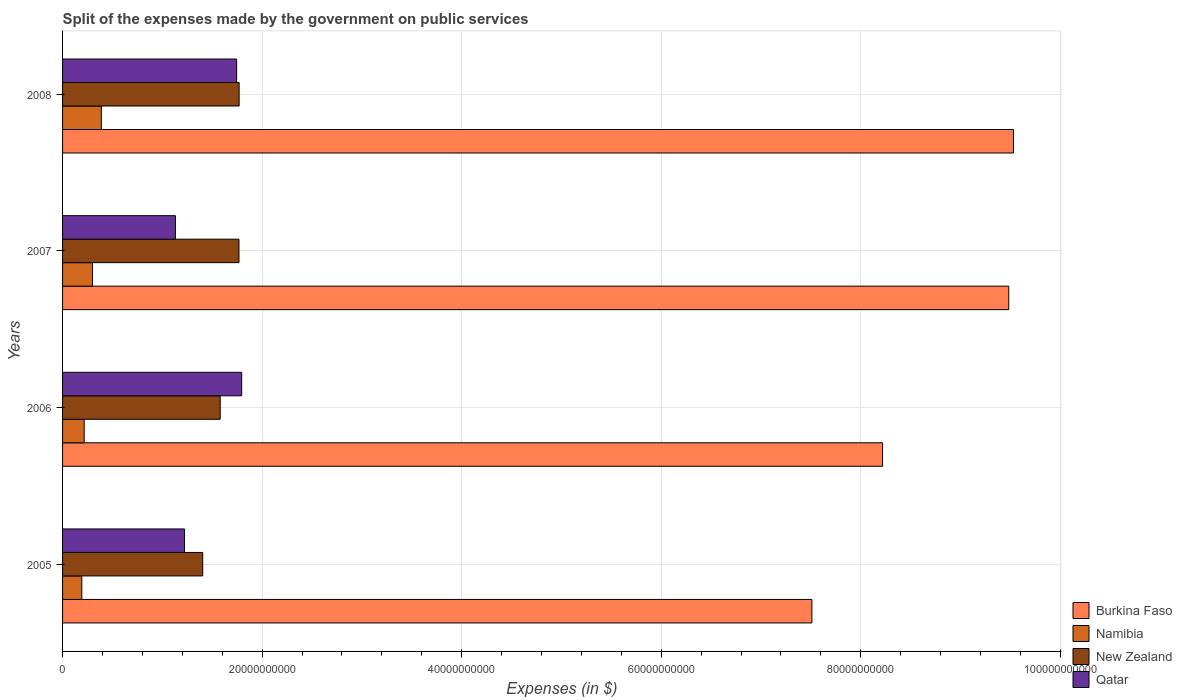How many different coloured bars are there?
Offer a very short reply. 4. How many groups of bars are there?
Offer a terse response. 4. Are the number of bars per tick equal to the number of legend labels?
Ensure brevity in your answer.  Yes. Are the number of bars on each tick of the Y-axis equal?
Keep it short and to the point. Yes. How many bars are there on the 3rd tick from the top?
Give a very brief answer. 4. What is the label of the 1st group of bars from the top?
Give a very brief answer. 2008. What is the expenses made by the government on public services in New Zealand in 2005?
Provide a short and direct response. 1.40e+1. Across all years, what is the maximum expenses made by the government on public services in Namibia?
Offer a very short reply. 3.89e+09. Across all years, what is the minimum expenses made by the government on public services in Qatar?
Ensure brevity in your answer.  1.13e+1. In which year was the expenses made by the government on public services in Qatar minimum?
Provide a succinct answer. 2007. What is the total expenses made by the government on public services in Namibia in the graph?
Offer a very short reply. 1.10e+1. What is the difference between the expenses made by the government on public services in Qatar in 2007 and that in 2008?
Provide a succinct answer. -6.14e+09. What is the difference between the expenses made by the government on public services in New Zealand in 2005 and the expenses made by the government on public services in Qatar in 2007?
Provide a succinct answer. 2.74e+09. What is the average expenses made by the government on public services in Burkina Faso per year?
Offer a very short reply. 8.69e+1. In the year 2006, what is the difference between the expenses made by the government on public services in Burkina Faso and expenses made by the government on public services in Namibia?
Offer a very short reply. 8.00e+1. What is the ratio of the expenses made by the government on public services in Qatar in 2007 to that in 2008?
Your answer should be compact. 0.65. Is the expenses made by the government on public services in Namibia in 2007 less than that in 2008?
Make the answer very short. Yes. Is the difference between the expenses made by the government on public services in Burkina Faso in 2005 and 2007 greater than the difference between the expenses made by the government on public services in Namibia in 2005 and 2007?
Your response must be concise. No. What is the difference between the highest and the second highest expenses made by the government on public services in Qatar?
Offer a very short reply. 5.07e+08. What is the difference between the highest and the lowest expenses made by the government on public services in New Zealand?
Provide a succinct answer. 3.65e+09. What does the 1st bar from the top in 2006 represents?
Provide a short and direct response. Qatar. What does the 3rd bar from the bottom in 2008 represents?
Ensure brevity in your answer.  New Zealand. How many bars are there?
Your answer should be very brief. 16. Are all the bars in the graph horizontal?
Provide a short and direct response. Yes. What is the difference between two consecutive major ticks on the X-axis?
Provide a short and direct response. 2.00e+1. Are the values on the major ticks of X-axis written in scientific E-notation?
Your response must be concise. No. Does the graph contain any zero values?
Offer a very short reply. No. How are the legend labels stacked?
Make the answer very short. Vertical. What is the title of the graph?
Give a very brief answer. Split of the expenses made by the government on public services. What is the label or title of the X-axis?
Your response must be concise. Expenses (in $). What is the Expenses (in $) in Burkina Faso in 2005?
Provide a succinct answer. 7.51e+1. What is the Expenses (in $) in Namibia in 2005?
Provide a short and direct response. 1.93e+09. What is the Expenses (in $) of New Zealand in 2005?
Keep it short and to the point. 1.40e+1. What is the Expenses (in $) in Qatar in 2005?
Your answer should be compact. 1.22e+1. What is the Expenses (in $) of Burkina Faso in 2006?
Give a very brief answer. 8.22e+1. What is the Expenses (in $) of Namibia in 2006?
Your answer should be very brief. 2.17e+09. What is the Expenses (in $) in New Zealand in 2006?
Offer a very short reply. 1.58e+1. What is the Expenses (in $) of Qatar in 2006?
Your response must be concise. 1.80e+1. What is the Expenses (in $) in Burkina Faso in 2007?
Your answer should be very brief. 9.48e+1. What is the Expenses (in $) in Namibia in 2007?
Make the answer very short. 3.00e+09. What is the Expenses (in $) in New Zealand in 2007?
Ensure brevity in your answer.  1.77e+1. What is the Expenses (in $) in Qatar in 2007?
Give a very brief answer. 1.13e+1. What is the Expenses (in $) of Burkina Faso in 2008?
Keep it short and to the point. 9.53e+1. What is the Expenses (in $) of Namibia in 2008?
Your answer should be very brief. 3.89e+09. What is the Expenses (in $) in New Zealand in 2008?
Provide a short and direct response. 1.77e+1. What is the Expenses (in $) of Qatar in 2008?
Your response must be concise. 1.74e+1. Across all years, what is the maximum Expenses (in $) of Burkina Faso?
Offer a terse response. 9.53e+1. Across all years, what is the maximum Expenses (in $) in Namibia?
Keep it short and to the point. 3.89e+09. Across all years, what is the maximum Expenses (in $) in New Zealand?
Your answer should be compact. 1.77e+1. Across all years, what is the maximum Expenses (in $) in Qatar?
Provide a short and direct response. 1.80e+1. Across all years, what is the minimum Expenses (in $) of Burkina Faso?
Give a very brief answer. 7.51e+1. Across all years, what is the minimum Expenses (in $) of Namibia?
Offer a terse response. 1.93e+09. Across all years, what is the minimum Expenses (in $) in New Zealand?
Provide a succinct answer. 1.40e+1. Across all years, what is the minimum Expenses (in $) in Qatar?
Give a very brief answer. 1.13e+1. What is the total Expenses (in $) in Burkina Faso in the graph?
Your answer should be compact. 3.47e+11. What is the total Expenses (in $) in Namibia in the graph?
Give a very brief answer. 1.10e+1. What is the total Expenses (in $) of New Zealand in the graph?
Your answer should be compact. 6.52e+1. What is the total Expenses (in $) of Qatar in the graph?
Your response must be concise. 5.89e+1. What is the difference between the Expenses (in $) in Burkina Faso in 2005 and that in 2006?
Make the answer very short. -7.08e+09. What is the difference between the Expenses (in $) in Namibia in 2005 and that in 2006?
Give a very brief answer. -2.37e+08. What is the difference between the Expenses (in $) in New Zealand in 2005 and that in 2006?
Your answer should be compact. -1.75e+09. What is the difference between the Expenses (in $) in Qatar in 2005 and that in 2006?
Keep it short and to the point. -5.73e+09. What is the difference between the Expenses (in $) of Burkina Faso in 2005 and that in 2007?
Provide a short and direct response. -1.97e+1. What is the difference between the Expenses (in $) in Namibia in 2005 and that in 2007?
Provide a succinct answer. -1.07e+09. What is the difference between the Expenses (in $) of New Zealand in 2005 and that in 2007?
Provide a succinct answer. -3.63e+09. What is the difference between the Expenses (in $) in Qatar in 2005 and that in 2007?
Offer a terse response. 9.13e+08. What is the difference between the Expenses (in $) in Burkina Faso in 2005 and that in 2008?
Offer a very short reply. -2.02e+1. What is the difference between the Expenses (in $) of Namibia in 2005 and that in 2008?
Provide a short and direct response. -1.96e+09. What is the difference between the Expenses (in $) of New Zealand in 2005 and that in 2008?
Ensure brevity in your answer.  -3.65e+09. What is the difference between the Expenses (in $) in Qatar in 2005 and that in 2008?
Your answer should be compact. -5.22e+09. What is the difference between the Expenses (in $) in Burkina Faso in 2006 and that in 2007?
Your answer should be very brief. -1.26e+1. What is the difference between the Expenses (in $) in Namibia in 2006 and that in 2007?
Provide a short and direct response. -8.32e+08. What is the difference between the Expenses (in $) in New Zealand in 2006 and that in 2007?
Your answer should be very brief. -1.88e+09. What is the difference between the Expenses (in $) in Qatar in 2006 and that in 2007?
Your answer should be compact. 6.64e+09. What is the difference between the Expenses (in $) in Burkina Faso in 2006 and that in 2008?
Offer a terse response. -1.31e+1. What is the difference between the Expenses (in $) in Namibia in 2006 and that in 2008?
Keep it short and to the point. -1.72e+09. What is the difference between the Expenses (in $) of New Zealand in 2006 and that in 2008?
Give a very brief answer. -1.90e+09. What is the difference between the Expenses (in $) in Qatar in 2006 and that in 2008?
Provide a short and direct response. 5.07e+08. What is the difference between the Expenses (in $) of Burkina Faso in 2007 and that in 2008?
Your answer should be very brief. -4.71e+08. What is the difference between the Expenses (in $) of Namibia in 2007 and that in 2008?
Give a very brief answer. -8.89e+08. What is the difference between the Expenses (in $) of New Zealand in 2007 and that in 2008?
Provide a short and direct response. -1.65e+07. What is the difference between the Expenses (in $) in Qatar in 2007 and that in 2008?
Ensure brevity in your answer.  -6.14e+09. What is the difference between the Expenses (in $) of Burkina Faso in 2005 and the Expenses (in $) of Namibia in 2006?
Make the answer very short. 7.29e+1. What is the difference between the Expenses (in $) of Burkina Faso in 2005 and the Expenses (in $) of New Zealand in 2006?
Keep it short and to the point. 5.93e+1. What is the difference between the Expenses (in $) in Burkina Faso in 2005 and the Expenses (in $) in Qatar in 2006?
Ensure brevity in your answer.  5.72e+1. What is the difference between the Expenses (in $) of Namibia in 2005 and the Expenses (in $) of New Zealand in 2006?
Ensure brevity in your answer.  -1.39e+1. What is the difference between the Expenses (in $) of Namibia in 2005 and the Expenses (in $) of Qatar in 2006?
Your response must be concise. -1.60e+1. What is the difference between the Expenses (in $) of New Zealand in 2005 and the Expenses (in $) of Qatar in 2006?
Provide a succinct answer. -3.90e+09. What is the difference between the Expenses (in $) of Burkina Faso in 2005 and the Expenses (in $) of Namibia in 2007?
Make the answer very short. 7.21e+1. What is the difference between the Expenses (in $) in Burkina Faso in 2005 and the Expenses (in $) in New Zealand in 2007?
Your answer should be very brief. 5.74e+1. What is the difference between the Expenses (in $) in Burkina Faso in 2005 and the Expenses (in $) in Qatar in 2007?
Keep it short and to the point. 6.38e+1. What is the difference between the Expenses (in $) in Namibia in 2005 and the Expenses (in $) in New Zealand in 2007?
Provide a short and direct response. -1.58e+1. What is the difference between the Expenses (in $) in Namibia in 2005 and the Expenses (in $) in Qatar in 2007?
Your response must be concise. -9.38e+09. What is the difference between the Expenses (in $) of New Zealand in 2005 and the Expenses (in $) of Qatar in 2007?
Your response must be concise. 2.74e+09. What is the difference between the Expenses (in $) in Burkina Faso in 2005 and the Expenses (in $) in Namibia in 2008?
Make the answer very short. 7.12e+1. What is the difference between the Expenses (in $) in Burkina Faso in 2005 and the Expenses (in $) in New Zealand in 2008?
Keep it short and to the point. 5.74e+1. What is the difference between the Expenses (in $) in Burkina Faso in 2005 and the Expenses (in $) in Qatar in 2008?
Your answer should be compact. 5.77e+1. What is the difference between the Expenses (in $) in Namibia in 2005 and the Expenses (in $) in New Zealand in 2008?
Provide a succinct answer. -1.58e+1. What is the difference between the Expenses (in $) of Namibia in 2005 and the Expenses (in $) of Qatar in 2008?
Your answer should be compact. -1.55e+1. What is the difference between the Expenses (in $) of New Zealand in 2005 and the Expenses (in $) of Qatar in 2008?
Give a very brief answer. -3.40e+09. What is the difference between the Expenses (in $) in Burkina Faso in 2006 and the Expenses (in $) in Namibia in 2007?
Offer a terse response. 7.92e+1. What is the difference between the Expenses (in $) in Burkina Faso in 2006 and the Expenses (in $) in New Zealand in 2007?
Offer a very short reply. 6.45e+1. What is the difference between the Expenses (in $) in Burkina Faso in 2006 and the Expenses (in $) in Qatar in 2007?
Give a very brief answer. 7.09e+1. What is the difference between the Expenses (in $) in Namibia in 2006 and the Expenses (in $) in New Zealand in 2007?
Provide a succinct answer. -1.55e+1. What is the difference between the Expenses (in $) in Namibia in 2006 and the Expenses (in $) in Qatar in 2007?
Your answer should be compact. -9.14e+09. What is the difference between the Expenses (in $) in New Zealand in 2006 and the Expenses (in $) in Qatar in 2007?
Ensure brevity in your answer.  4.49e+09. What is the difference between the Expenses (in $) of Burkina Faso in 2006 and the Expenses (in $) of Namibia in 2008?
Provide a succinct answer. 7.83e+1. What is the difference between the Expenses (in $) in Burkina Faso in 2006 and the Expenses (in $) in New Zealand in 2008?
Give a very brief answer. 6.45e+1. What is the difference between the Expenses (in $) in Burkina Faso in 2006 and the Expenses (in $) in Qatar in 2008?
Give a very brief answer. 6.47e+1. What is the difference between the Expenses (in $) of Namibia in 2006 and the Expenses (in $) of New Zealand in 2008?
Provide a short and direct response. -1.55e+1. What is the difference between the Expenses (in $) of Namibia in 2006 and the Expenses (in $) of Qatar in 2008?
Offer a very short reply. -1.53e+1. What is the difference between the Expenses (in $) in New Zealand in 2006 and the Expenses (in $) in Qatar in 2008?
Provide a short and direct response. -1.65e+09. What is the difference between the Expenses (in $) of Burkina Faso in 2007 and the Expenses (in $) of Namibia in 2008?
Keep it short and to the point. 9.10e+1. What is the difference between the Expenses (in $) in Burkina Faso in 2007 and the Expenses (in $) in New Zealand in 2008?
Keep it short and to the point. 7.71e+1. What is the difference between the Expenses (in $) of Burkina Faso in 2007 and the Expenses (in $) of Qatar in 2008?
Provide a succinct answer. 7.74e+1. What is the difference between the Expenses (in $) of Namibia in 2007 and the Expenses (in $) of New Zealand in 2008?
Make the answer very short. -1.47e+1. What is the difference between the Expenses (in $) in Namibia in 2007 and the Expenses (in $) in Qatar in 2008?
Give a very brief answer. -1.44e+1. What is the difference between the Expenses (in $) in New Zealand in 2007 and the Expenses (in $) in Qatar in 2008?
Offer a terse response. 2.35e+08. What is the average Expenses (in $) of Burkina Faso per year?
Offer a terse response. 8.69e+1. What is the average Expenses (in $) in Namibia per year?
Your response must be concise. 2.74e+09. What is the average Expenses (in $) of New Zealand per year?
Your answer should be compact. 1.63e+1. What is the average Expenses (in $) in Qatar per year?
Offer a terse response. 1.47e+1. In the year 2005, what is the difference between the Expenses (in $) of Burkina Faso and Expenses (in $) of Namibia?
Make the answer very short. 7.32e+1. In the year 2005, what is the difference between the Expenses (in $) of Burkina Faso and Expenses (in $) of New Zealand?
Offer a very short reply. 6.11e+1. In the year 2005, what is the difference between the Expenses (in $) of Burkina Faso and Expenses (in $) of Qatar?
Ensure brevity in your answer.  6.29e+1. In the year 2005, what is the difference between the Expenses (in $) in Namibia and Expenses (in $) in New Zealand?
Give a very brief answer. -1.21e+1. In the year 2005, what is the difference between the Expenses (in $) in Namibia and Expenses (in $) in Qatar?
Your answer should be compact. -1.03e+1. In the year 2005, what is the difference between the Expenses (in $) of New Zealand and Expenses (in $) of Qatar?
Offer a very short reply. 1.83e+09. In the year 2006, what is the difference between the Expenses (in $) in Burkina Faso and Expenses (in $) in Namibia?
Your response must be concise. 8.00e+1. In the year 2006, what is the difference between the Expenses (in $) of Burkina Faso and Expenses (in $) of New Zealand?
Offer a terse response. 6.64e+1. In the year 2006, what is the difference between the Expenses (in $) in Burkina Faso and Expenses (in $) in Qatar?
Your answer should be very brief. 6.42e+1. In the year 2006, what is the difference between the Expenses (in $) in Namibia and Expenses (in $) in New Zealand?
Your answer should be very brief. -1.36e+1. In the year 2006, what is the difference between the Expenses (in $) of Namibia and Expenses (in $) of Qatar?
Make the answer very short. -1.58e+1. In the year 2006, what is the difference between the Expenses (in $) of New Zealand and Expenses (in $) of Qatar?
Provide a short and direct response. -2.15e+09. In the year 2007, what is the difference between the Expenses (in $) in Burkina Faso and Expenses (in $) in Namibia?
Ensure brevity in your answer.  9.18e+1. In the year 2007, what is the difference between the Expenses (in $) in Burkina Faso and Expenses (in $) in New Zealand?
Your response must be concise. 7.72e+1. In the year 2007, what is the difference between the Expenses (in $) of Burkina Faso and Expenses (in $) of Qatar?
Provide a short and direct response. 8.35e+1. In the year 2007, what is the difference between the Expenses (in $) of Namibia and Expenses (in $) of New Zealand?
Offer a terse response. -1.47e+1. In the year 2007, what is the difference between the Expenses (in $) of Namibia and Expenses (in $) of Qatar?
Provide a short and direct response. -8.31e+09. In the year 2007, what is the difference between the Expenses (in $) in New Zealand and Expenses (in $) in Qatar?
Ensure brevity in your answer.  6.37e+09. In the year 2008, what is the difference between the Expenses (in $) in Burkina Faso and Expenses (in $) in Namibia?
Ensure brevity in your answer.  9.14e+1. In the year 2008, what is the difference between the Expenses (in $) of Burkina Faso and Expenses (in $) of New Zealand?
Ensure brevity in your answer.  7.76e+1. In the year 2008, what is the difference between the Expenses (in $) in Burkina Faso and Expenses (in $) in Qatar?
Make the answer very short. 7.79e+1. In the year 2008, what is the difference between the Expenses (in $) in Namibia and Expenses (in $) in New Zealand?
Your answer should be very brief. -1.38e+1. In the year 2008, what is the difference between the Expenses (in $) of Namibia and Expenses (in $) of Qatar?
Your answer should be very brief. -1.36e+1. In the year 2008, what is the difference between the Expenses (in $) in New Zealand and Expenses (in $) in Qatar?
Your response must be concise. 2.52e+08. What is the ratio of the Expenses (in $) in Burkina Faso in 2005 to that in 2006?
Your answer should be very brief. 0.91. What is the ratio of the Expenses (in $) of Namibia in 2005 to that in 2006?
Keep it short and to the point. 0.89. What is the ratio of the Expenses (in $) of New Zealand in 2005 to that in 2006?
Give a very brief answer. 0.89. What is the ratio of the Expenses (in $) of Qatar in 2005 to that in 2006?
Your response must be concise. 0.68. What is the ratio of the Expenses (in $) in Burkina Faso in 2005 to that in 2007?
Give a very brief answer. 0.79. What is the ratio of the Expenses (in $) of Namibia in 2005 to that in 2007?
Provide a short and direct response. 0.64. What is the ratio of the Expenses (in $) in New Zealand in 2005 to that in 2007?
Give a very brief answer. 0.79. What is the ratio of the Expenses (in $) in Qatar in 2005 to that in 2007?
Your answer should be compact. 1.08. What is the ratio of the Expenses (in $) of Burkina Faso in 2005 to that in 2008?
Offer a very short reply. 0.79. What is the ratio of the Expenses (in $) in Namibia in 2005 to that in 2008?
Keep it short and to the point. 0.5. What is the ratio of the Expenses (in $) in New Zealand in 2005 to that in 2008?
Provide a succinct answer. 0.79. What is the ratio of the Expenses (in $) in Qatar in 2005 to that in 2008?
Offer a terse response. 0.7. What is the ratio of the Expenses (in $) in Burkina Faso in 2006 to that in 2007?
Ensure brevity in your answer.  0.87. What is the ratio of the Expenses (in $) in Namibia in 2006 to that in 2007?
Provide a short and direct response. 0.72. What is the ratio of the Expenses (in $) in New Zealand in 2006 to that in 2007?
Offer a terse response. 0.89. What is the ratio of the Expenses (in $) in Qatar in 2006 to that in 2007?
Provide a short and direct response. 1.59. What is the ratio of the Expenses (in $) in Burkina Faso in 2006 to that in 2008?
Keep it short and to the point. 0.86. What is the ratio of the Expenses (in $) in Namibia in 2006 to that in 2008?
Provide a succinct answer. 0.56. What is the ratio of the Expenses (in $) in New Zealand in 2006 to that in 2008?
Offer a terse response. 0.89. What is the ratio of the Expenses (in $) in Qatar in 2006 to that in 2008?
Your response must be concise. 1.03. What is the ratio of the Expenses (in $) of Burkina Faso in 2007 to that in 2008?
Give a very brief answer. 1. What is the ratio of the Expenses (in $) in Namibia in 2007 to that in 2008?
Give a very brief answer. 0.77. What is the ratio of the Expenses (in $) of Qatar in 2007 to that in 2008?
Keep it short and to the point. 0.65. What is the difference between the highest and the second highest Expenses (in $) in Burkina Faso?
Your response must be concise. 4.71e+08. What is the difference between the highest and the second highest Expenses (in $) in Namibia?
Offer a terse response. 8.89e+08. What is the difference between the highest and the second highest Expenses (in $) in New Zealand?
Your answer should be compact. 1.65e+07. What is the difference between the highest and the second highest Expenses (in $) of Qatar?
Make the answer very short. 5.07e+08. What is the difference between the highest and the lowest Expenses (in $) in Burkina Faso?
Your answer should be very brief. 2.02e+1. What is the difference between the highest and the lowest Expenses (in $) of Namibia?
Your answer should be compact. 1.96e+09. What is the difference between the highest and the lowest Expenses (in $) in New Zealand?
Ensure brevity in your answer.  3.65e+09. What is the difference between the highest and the lowest Expenses (in $) of Qatar?
Provide a succinct answer. 6.64e+09. 